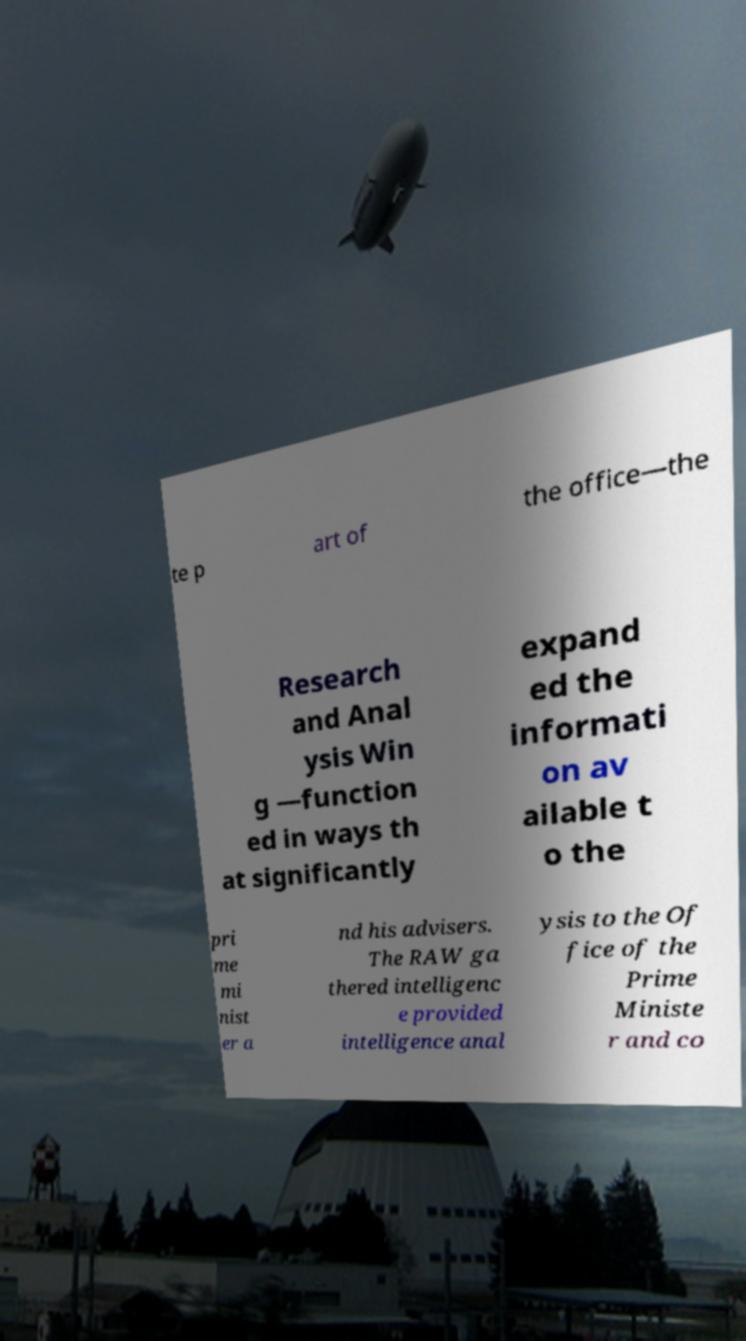Could you extract and type out the text from this image? te p art of the office—the Research and Anal ysis Win g —function ed in ways th at significantly expand ed the informati on av ailable t o the pri me mi nist er a nd his advisers. The RAW ga thered intelligenc e provided intelligence anal ysis to the Of fice of the Prime Ministe r and co 